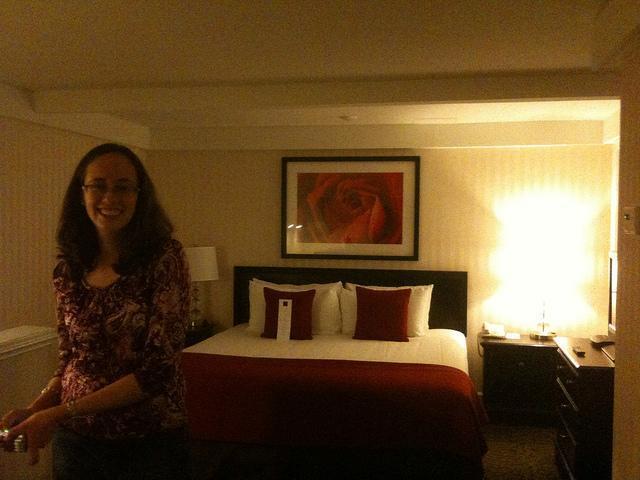How many people are in the picture?
Give a very brief answer. 1. 